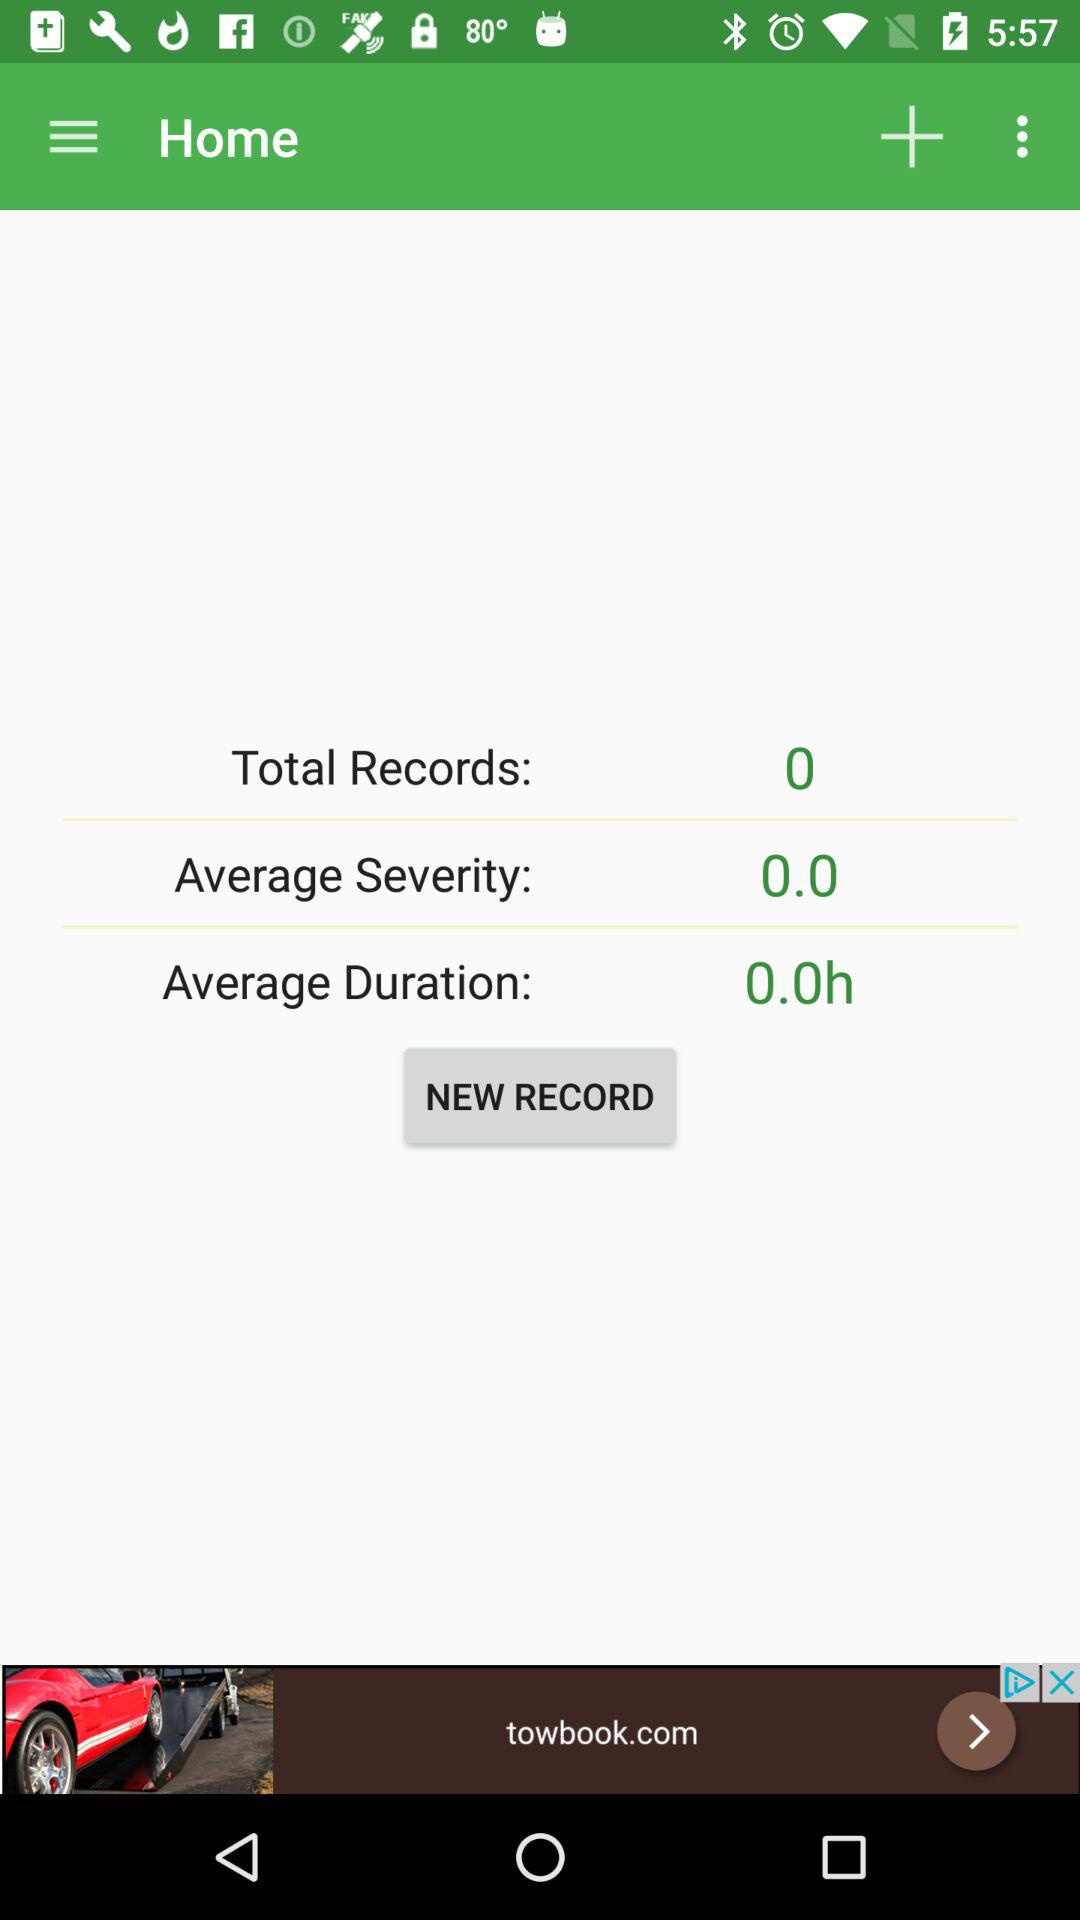What is the average severity of all records?
Answer the question using a single word or phrase. 0.0 